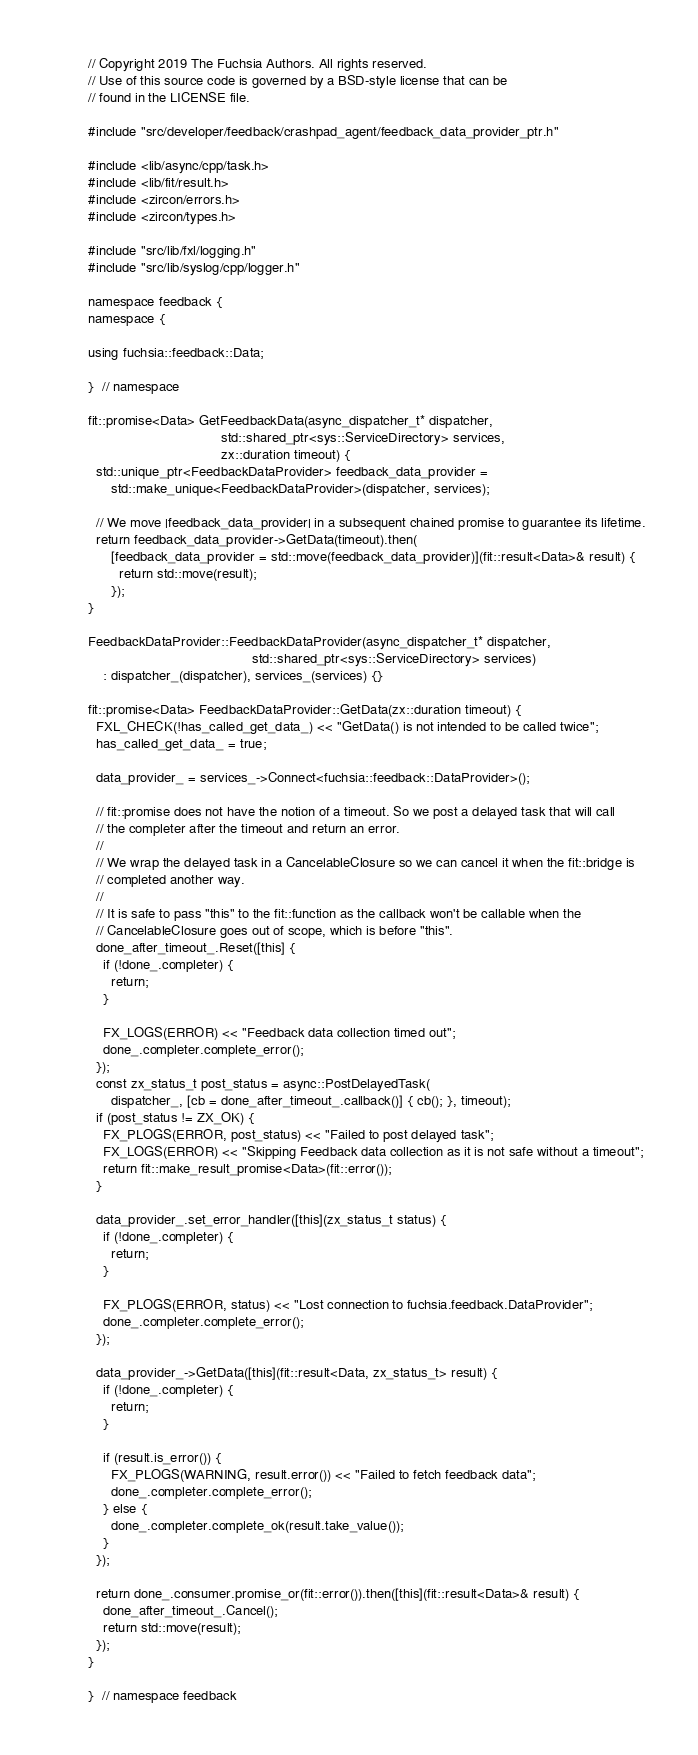<code> <loc_0><loc_0><loc_500><loc_500><_C++_>// Copyright 2019 The Fuchsia Authors. All rights reserved.
// Use of this source code is governed by a BSD-style license that can be
// found in the LICENSE file.

#include "src/developer/feedback/crashpad_agent/feedback_data_provider_ptr.h"

#include <lib/async/cpp/task.h>
#include <lib/fit/result.h>
#include <zircon/errors.h>
#include <zircon/types.h>

#include "src/lib/fxl/logging.h"
#include "src/lib/syslog/cpp/logger.h"

namespace feedback {
namespace {

using fuchsia::feedback::Data;

}  // namespace

fit::promise<Data> GetFeedbackData(async_dispatcher_t* dispatcher,
                                   std::shared_ptr<sys::ServiceDirectory> services,
                                   zx::duration timeout) {
  std::unique_ptr<FeedbackDataProvider> feedback_data_provider =
      std::make_unique<FeedbackDataProvider>(dispatcher, services);

  // We move |feedback_data_provider| in a subsequent chained promise to guarantee its lifetime.
  return feedback_data_provider->GetData(timeout).then(
      [feedback_data_provider = std::move(feedback_data_provider)](fit::result<Data>& result) {
        return std::move(result);
      });
}

FeedbackDataProvider::FeedbackDataProvider(async_dispatcher_t* dispatcher,
                                           std::shared_ptr<sys::ServiceDirectory> services)
    : dispatcher_(dispatcher), services_(services) {}

fit::promise<Data> FeedbackDataProvider::GetData(zx::duration timeout) {
  FXL_CHECK(!has_called_get_data_) << "GetData() is not intended to be called twice";
  has_called_get_data_ = true;

  data_provider_ = services_->Connect<fuchsia::feedback::DataProvider>();

  // fit::promise does not have the notion of a timeout. So we post a delayed task that will call
  // the completer after the timeout and return an error.
  //
  // We wrap the delayed task in a CancelableClosure so we can cancel it when the fit::bridge is
  // completed another way.
  //
  // It is safe to pass "this" to the fit::function as the callback won't be callable when the
  // CancelableClosure goes out of scope, which is before "this".
  done_after_timeout_.Reset([this] {
    if (!done_.completer) {
      return;
    }

    FX_LOGS(ERROR) << "Feedback data collection timed out";
    done_.completer.complete_error();
  });
  const zx_status_t post_status = async::PostDelayedTask(
      dispatcher_, [cb = done_after_timeout_.callback()] { cb(); }, timeout);
  if (post_status != ZX_OK) {
    FX_PLOGS(ERROR, post_status) << "Failed to post delayed task";
    FX_LOGS(ERROR) << "Skipping Feedback data collection as it is not safe without a timeout";
    return fit::make_result_promise<Data>(fit::error());
  }

  data_provider_.set_error_handler([this](zx_status_t status) {
    if (!done_.completer) {
      return;
    }

    FX_PLOGS(ERROR, status) << "Lost connection to fuchsia.feedback.DataProvider";
    done_.completer.complete_error();
  });

  data_provider_->GetData([this](fit::result<Data, zx_status_t> result) {
    if (!done_.completer) {
      return;
    }

    if (result.is_error()) {
      FX_PLOGS(WARNING, result.error()) << "Failed to fetch feedback data";
      done_.completer.complete_error();
    } else {
      done_.completer.complete_ok(result.take_value());
    }
  });

  return done_.consumer.promise_or(fit::error()).then([this](fit::result<Data>& result) {
    done_after_timeout_.Cancel();
    return std::move(result);
  });
}

}  // namespace feedback
</code> 